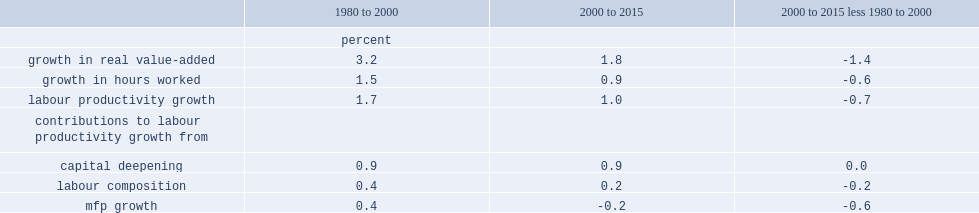What's the percent of output growth was per year from 1980 to 2000? 3.2. What's the percent of output growth was per year from 2000 to 2015? 1.8. What's the percent of labour productivity growth was per year over the period from 1980 to 2000? 1.7. What's the percent of labour productivity growth was per year over the period from 2000 to 2015? 1.0. What's the percent of the decline of labour productivity growth after 2000? 0.7. What's the percent of mfp growth per year in the period from 1980 to 2000? 0.4. What's the percent of mfp growth per year in the period from 2000 to 2015? 0.2. What's the percent of labour compositional effects from 1980 to 2000? 0.4. What's the percent of labour compositional effects from 2000 to 2015? 0.2. 